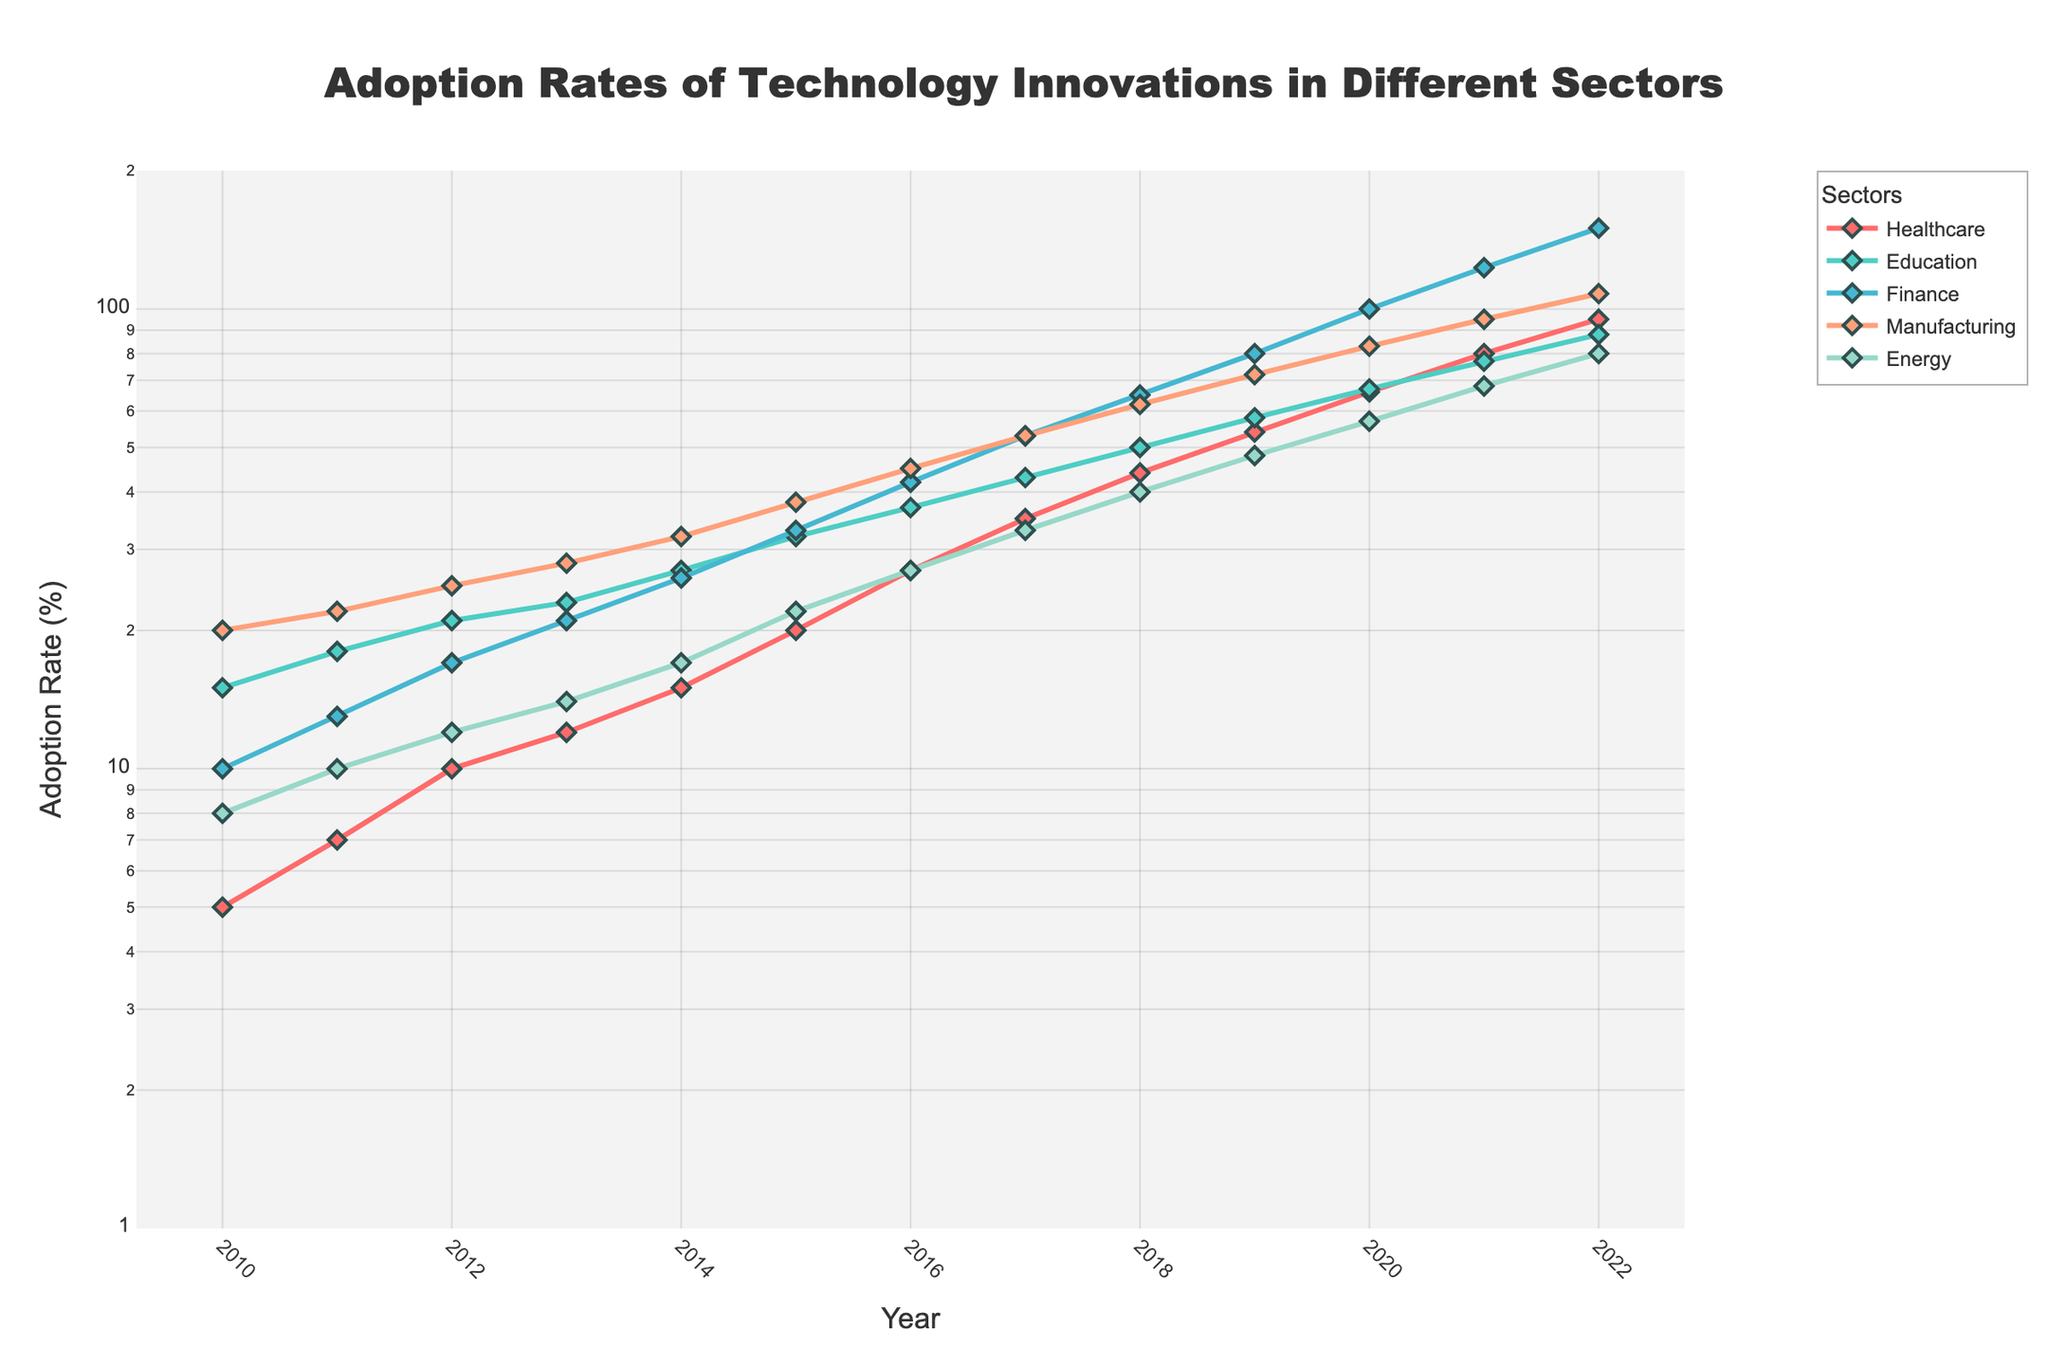What is the title of the figure? The title is usually placed at the top center of the figure. In this case, the title reads "Adoption Rates of Technology Innovations in Different Sectors" as indicated in the code.
Answer: Adoption Rates of Technology Innovations in Different Sectors What is the adoption rate for Healthcare in 2012? Locate the year 2012 on the x-axis, then find the corresponding y-value for the Healthcare line, which is highlighted by a specific color. For 2012, the adoption rate for Healthcare is 10%.
Answer: 10% Which sector had the highest adoption rate in 2022? Find the year 2022 on the x-axis, then compare the y-values for all sectors. The sector with the highest y-value in 2022 is Finance with an adoption rate of 150%.
Answer: Finance How does the adoption rate for Manufacturing change from 2015 to 2017? Locate the years 2015 and 2017 on the x-axis and observe the y-values for Manufacturing. In 2015, it is 38%, and in 2017, it is 53%. Calculate the change: 53% - 38% = 15%.
Answer: Increased by 15% Which sector shows the most consistent growth over the years? Look at the trends of each line, and identify the line that shows a steady and consistent upward trend. The Healthcare sector shows a consistent growth as the line steadily rises every year.
Answer: Healthcare When did Energy first reach an adoption rate of 40%? Find the year on the x-axis where the Energy line (identified by its specific color) first exceeds the 40% mark. This occurs in 2018.
Answer: 2018 Compare the adoption rates of Healthcare and Education in 2020. Which one is higher and by how much? Locate the year 2020 on the x-axis, then find the y-values for both Healthcare and Education. Healthcare is at 66% and Education at 67%. The difference is 67% - 66% = 1%.
Answer: Education by 1% What is the trend in adoption rate for the Finance sector from 2017 to 2020? Look at the line corresponding to the Finance sector from the year 2017 to 2020. The y-value increases from 53% in 2017 to 100% in 2020, showing an upward trend.
Answer: Upward trend What can be observed about the adoption rate of Energy as compared to Manufacturing over the whole period? Compare the trend lines of Energy and Manufacturing from 2010 to 2022. Energy has a generally slower and more gradual increase as compared to the consistently higher adoption rates for Manufacturing.
Answer: Manufacturing is consistently higher Which sector had the least adoption rate in 2015, and what was that rate? Find the year 2015 on the x-axis and compare y-values of all sectors. The least adoption rate, 20%, was for Healthcare.
Answer: Healthcare, 20% 